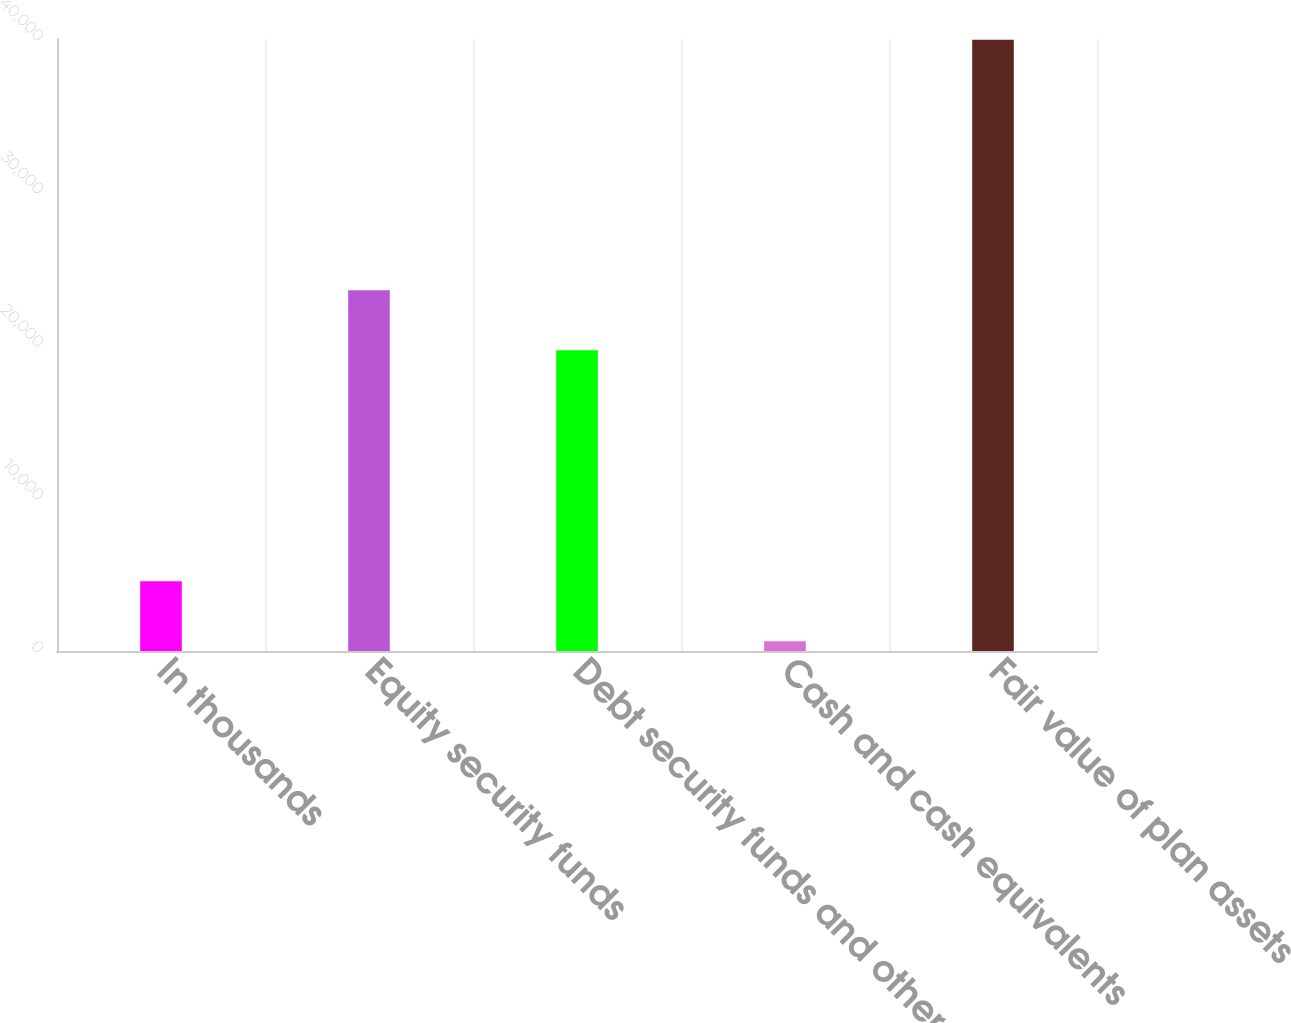<chart> <loc_0><loc_0><loc_500><loc_500><bar_chart><fcel>In thousands<fcel>Equity security funds<fcel>Debt security funds and other<fcel>Cash and cash equivalents<fcel>Fair value of plan assets<nl><fcel>4563.9<fcel>23581.9<fcel>19650<fcel>632<fcel>39951<nl></chart> 